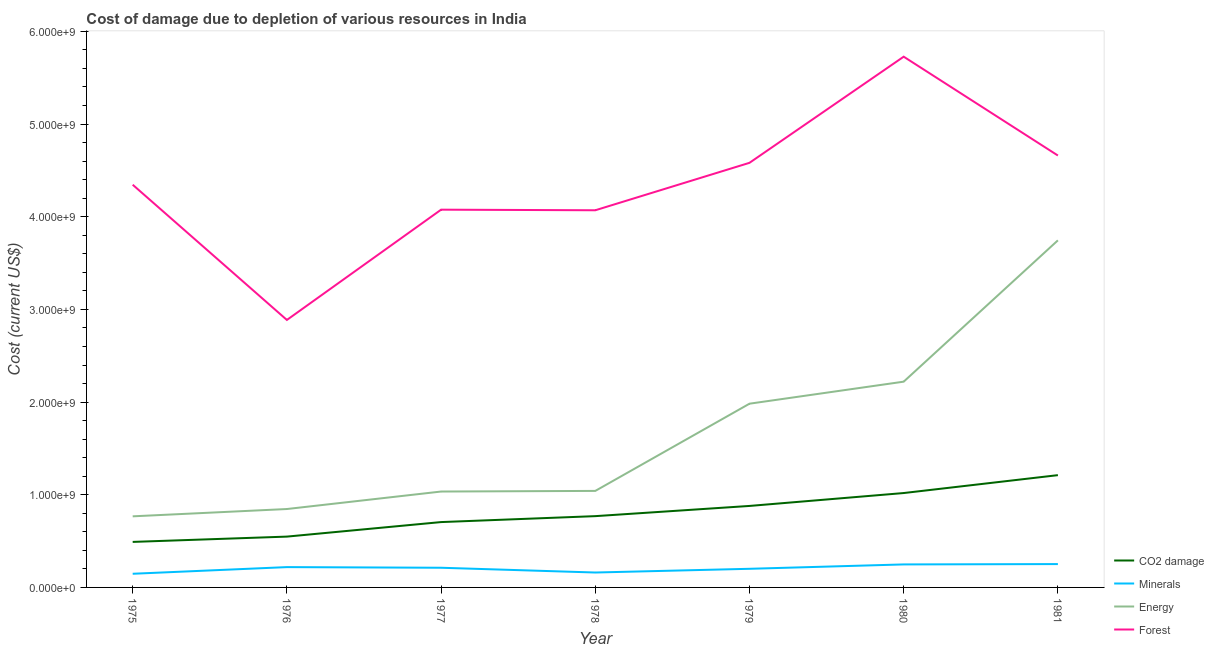What is the cost of damage due to depletion of coal in 1979?
Your response must be concise. 8.79e+08. Across all years, what is the maximum cost of damage due to depletion of minerals?
Give a very brief answer. 2.52e+08. Across all years, what is the minimum cost of damage due to depletion of forests?
Make the answer very short. 2.89e+09. In which year was the cost of damage due to depletion of energy minimum?
Provide a succinct answer. 1975. What is the total cost of damage due to depletion of coal in the graph?
Your response must be concise. 5.62e+09. What is the difference between the cost of damage due to depletion of forests in 1976 and that in 1978?
Keep it short and to the point. -1.18e+09. What is the difference between the cost of damage due to depletion of minerals in 1978 and the cost of damage due to depletion of forests in 1976?
Ensure brevity in your answer.  -2.73e+09. What is the average cost of damage due to depletion of minerals per year?
Keep it short and to the point. 2.06e+08. In the year 1978, what is the difference between the cost of damage due to depletion of energy and cost of damage due to depletion of forests?
Make the answer very short. -3.03e+09. What is the ratio of the cost of damage due to depletion of forests in 1978 to that in 1980?
Make the answer very short. 0.71. Is the cost of damage due to depletion of forests in 1975 less than that in 1976?
Make the answer very short. No. Is the difference between the cost of damage due to depletion of forests in 1976 and 1981 greater than the difference between the cost of damage due to depletion of coal in 1976 and 1981?
Keep it short and to the point. No. What is the difference between the highest and the second highest cost of damage due to depletion of coal?
Your response must be concise. 1.93e+08. What is the difference between the highest and the lowest cost of damage due to depletion of minerals?
Your response must be concise. 1.05e+08. Is it the case that in every year, the sum of the cost of damage due to depletion of coal and cost of damage due to depletion of minerals is greater than the cost of damage due to depletion of energy?
Give a very brief answer. No. Is the cost of damage due to depletion of coal strictly greater than the cost of damage due to depletion of energy over the years?
Your answer should be compact. No. How many lines are there?
Provide a succinct answer. 4. How many years are there in the graph?
Provide a short and direct response. 7. Are the values on the major ticks of Y-axis written in scientific E-notation?
Offer a terse response. Yes. Where does the legend appear in the graph?
Keep it short and to the point. Bottom right. How many legend labels are there?
Make the answer very short. 4. What is the title of the graph?
Keep it short and to the point. Cost of damage due to depletion of various resources in India . Does "Australia" appear as one of the legend labels in the graph?
Offer a terse response. No. What is the label or title of the X-axis?
Offer a terse response. Year. What is the label or title of the Y-axis?
Keep it short and to the point. Cost (current US$). What is the Cost (current US$) in CO2 damage in 1975?
Provide a succinct answer. 4.91e+08. What is the Cost (current US$) of Minerals in 1975?
Your response must be concise. 1.47e+08. What is the Cost (current US$) in Energy in 1975?
Provide a short and direct response. 7.67e+08. What is the Cost (current US$) in Forest in 1975?
Your answer should be compact. 4.35e+09. What is the Cost (current US$) of CO2 damage in 1976?
Offer a very short reply. 5.48e+08. What is the Cost (current US$) in Minerals in 1976?
Give a very brief answer. 2.19e+08. What is the Cost (current US$) in Energy in 1976?
Give a very brief answer. 8.46e+08. What is the Cost (current US$) in Forest in 1976?
Keep it short and to the point. 2.89e+09. What is the Cost (current US$) of CO2 damage in 1977?
Give a very brief answer. 7.05e+08. What is the Cost (current US$) of Minerals in 1977?
Your answer should be very brief. 2.12e+08. What is the Cost (current US$) of Energy in 1977?
Ensure brevity in your answer.  1.03e+09. What is the Cost (current US$) in Forest in 1977?
Offer a very short reply. 4.08e+09. What is the Cost (current US$) in CO2 damage in 1978?
Provide a short and direct response. 7.69e+08. What is the Cost (current US$) in Minerals in 1978?
Your answer should be very brief. 1.61e+08. What is the Cost (current US$) of Energy in 1978?
Provide a succinct answer. 1.04e+09. What is the Cost (current US$) in Forest in 1978?
Your answer should be compact. 4.07e+09. What is the Cost (current US$) in CO2 damage in 1979?
Provide a succinct answer. 8.79e+08. What is the Cost (current US$) of Minerals in 1979?
Ensure brevity in your answer.  2.01e+08. What is the Cost (current US$) in Energy in 1979?
Your response must be concise. 1.98e+09. What is the Cost (current US$) in Forest in 1979?
Your answer should be very brief. 4.58e+09. What is the Cost (current US$) of CO2 damage in 1980?
Your answer should be very brief. 1.02e+09. What is the Cost (current US$) in Minerals in 1980?
Provide a succinct answer. 2.48e+08. What is the Cost (current US$) of Energy in 1980?
Provide a succinct answer. 2.22e+09. What is the Cost (current US$) in Forest in 1980?
Give a very brief answer. 5.73e+09. What is the Cost (current US$) in CO2 damage in 1981?
Offer a very short reply. 1.21e+09. What is the Cost (current US$) in Minerals in 1981?
Keep it short and to the point. 2.52e+08. What is the Cost (current US$) in Energy in 1981?
Give a very brief answer. 3.75e+09. What is the Cost (current US$) in Forest in 1981?
Your answer should be very brief. 4.66e+09. Across all years, what is the maximum Cost (current US$) in CO2 damage?
Offer a terse response. 1.21e+09. Across all years, what is the maximum Cost (current US$) in Minerals?
Your answer should be very brief. 2.52e+08. Across all years, what is the maximum Cost (current US$) in Energy?
Ensure brevity in your answer.  3.75e+09. Across all years, what is the maximum Cost (current US$) of Forest?
Offer a very short reply. 5.73e+09. Across all years, what is the minimum Cost (current US$) of CO2 damage?
Provide a short and direct response. 4.91e+08. Across all years, what is the minimum Cost (current US$) in Minerals?
Your answer should be compact. 1.47e+08. Across all years, what is the minimum Cost (current US$) in Energy?
Make the answer very short. 7.67e+08. Across all years, what is the minimum Cost (current US$) in Forest?
Offer a very short reply. 2.89e+09. What is the total Cost (current US$) in CO2 damage in the graph?
Your response must be concise. 5.62e+09. What is the total Cost (current US$) of Minerals in the graph?
Offer a terse response. 1.44e+09. What is the total Cost (current US$) in Energy in the graph?
Provide a succinct answer. 1.16e+1. What is the total Cost (current US$) of Forest in the graph?
Your answer should be compact. 3.03e+1. What is the difference between the Cost (current US$) of CO2 damage in 1975 and that in 1976?
Your response must be concise. -5.71e+07. What is the difference between the Cost (current US$) of Minerals in 1975 and that in 1976?
Make the answer very short. -7.18e+07. What is the difference between the Cost (current US$) of Energy in 1975 and that in 1976?
Your response must be concise. -7.88e+07. What is the difference between the Cost (current US$) in Forest in 1975 and that in 1976?
Provide a short and direct response. 1.46e+09. What is the difference between the Cost (current US$) in CO2 damage in 1975 and that in 1977?
Give a very brief answer. -2.14e+08. What is the difference between the Cost (current US$) in Minerals in 1975 and that in 1977?
Provide a succinct answer. -6.49e+07. What is the difference between the Cost (current US$) of Energy in 1975 and that in 1977?
Provide a short and direct response. -2.67e+08. What is the difference between the Cost (current US$) in Forest in 1975 and that in 1977?
Provide a short and direct response. 2.69e+08. What is the difference between the Cost (current US$) in CO2 damage in 1975 and that in 1978?
Provide a short and direct response. -2.78e+08. What is the difference between the Cost (current US$) in Minerals in 1975 and that in 1978?
Give a very brief answer. -1.35e+07. What is the difference between the Cost (current US$) of Energy in 1975 and that in 1978?
Keep it short and to the point. -2.74e+08. What is the difference between the Cost (current US$) in Forest in 1975 and that in 1978?
Your answer should be very brief. 2.76e+08. What is the difference between the Cost (current US$) of CO2 damage in 1975 and that in 1979?
Your answer should be compact. -3.88e+08. What is the difference between the Cost (current US$) in Minerals in 1975 and that in 1979?
Give a very brief answer. -5.36e+07. What is the difference between the Cost (current US$) in Energy in 1975 and that in 1979?
Keep it short and to the point. -1.22e+09. What is the difference between the Cost (current US$) in Forest in 1975 and that in 1979?
Provide a short and direct response. -2.36e+08. What is the difference between the Cost (current US$) of CO2 damage in 1975 and that in 1980?
Make the answer very short. -5.27e+08. What is the difference between the Cost (current US$) in Minerals in 1975 and that in 1980?
Your answer should be very brief. -1.01e+08. What is the difference between the Cost (current US$) of Energy in 1975 and that in 1980?
Your answer should be very brief. -1.45e+09. What is the difference between the Cost (current US$) in Forest in 1975 and that in 1980?
Offer a very short reply. -1.38e+09. What is the difference between the Cost (current US$) of CO2 damage in 1975 and that in 1981?
Your response must be concise. -7.20e+08. What is the difference between the Cost (current US$) in Minerals in 1975 and that in 1981?
Provide a succinct answer. -1.05e+08. What is the difference between the Cost (current US$) of Energy in 1975 and that in 1981?
Offer a terse response. -2.98e+09. What is the difference between the Cost (current US$) in Forest in 1975 and that in 1981?
Your answer should be compact. -3.15e+08. What is the difference between the Cost (current US$) of CO2 damage in 1976 and that in 1977?
Your answer should be compact. -1.57e+08. What is the difference between the Cost (current US$) in Minerals in 1976 and that in 1977?
Offer a very short reply. 6.86e+06. What is the difference between the Cost (current US$) in Energy in 1976 and that in 1977?
Keep it short and to the point. -1.89e+08. What is the difference between the Cost (current US$) in Forest in 1976 and that in 1977?
Give a very brief answer. -1.19e+09. What is the difference between the Cost (current US$) of CO2 damage in 1976 and that in 1978?
Your answer should be very brief. -2.21e+08. What is the difference between the Cost (current US$) in Minerals in 1976 and that in 1978?
Offer a terse response. 5.84e+07. What is the difference between the Cost (current US$) in Energy in 1976 and that in 1978?
Your answer should be compact. -1.95e+08. What is the difference between the Cost (current US$) of Forest in 1976 and that in 1978?
Give a very brief answer. -1.18e+09. What is the difference between the Cost (current US$) in CO2 damage in 1976 and that in 1979?
Your answer should be compact. -3.31e+08. What is the difference between the Cost (current US$) of Minerals in 1976 and that in 1979?
Make the answer very short. 1.82e+07. What is the difference between the Cost (current US$) in Energy in 1976 and that in 1979?
Offer a very short reply. -1.14e+09. What is the difference between the Cost (current US$) of Forest in 1976 and that in 1979?
Keep it short and to the point. -1.70e+09. What is the difference between the Cost (current US$) of CO2 damage in 1976 and that in 1980?
Your answer should be very brief. -4.70e+08. What is the difference between the Cost (current US$) in Minerals in 1976 and that in 1980?
Your response must be concise. -2.91e+07. What is the difference between the Cost (current US$) in Energy in 1976 and that in 1980?
Offer a terse response. -1.37e+09. What is the difference between the Cost (current US$) in Forest in 1976 and that in 1980?
Provide a short and direct response. -2.84e+09. What is the difference between the Cost (current US$) in CO2 damage in 1976 and that in 1981?
Make the answer very short. -6.63e+08. What is the difference between the Cost (current US$) in Minerals in 1976 and that in 1981?
Offer a very short reply. -3.27e+07. What is the difference between the Cost (current US$) in Energy in 1976 and that in 1981?
Your answer should be very brief. -2.90e+09. What is the difference between the Cost (current US$) in Forest in 1976 and that in 1981?
Offer a terse response. -1.77e+09. What is the difference between the Cost (current US$) of CO2 damage in 1977 and that in 1978?
Offer a very short reply. -6.41e+07. What is the difference between the Cost (current US$) of Minerals in 1977 and that in 1978?
Keep it short and to the point. 5.15e+07. What is the difference between the Cost (current US$) in Energy in 1977 and that in 1978?
Provide a succinct answer. -6.77e+06. What is the difference between the Cost (current US$) in Forest in 1977 and that in 1978?
Your answer should be compact. 6.45e+06. What is the difference between the Cost (current US$) of CO2 damage in 1977 and that in 1979?
Give a very brief answer. -1.74e+08. What is the difference between the Cost (current US$) of Minerals in 1977 and that in 1979?
Make the answer very short. 1.14e+07. What is the difference between the Cost (current US$) of Energy in 1977 and that in 1979?
Ensure brevity in your answer.  -9.48e+08. What is the difference between the Cost (current US$) in Forest in 1977 and that in 1979?
Give a very brief answer. -5.06e+08. What is the difference between the Cost (current US$) of CO2 damage in 1977 and that in 1980?
Offer a terse response. -3.13e+08. What is the difference between the Cost (current US$) in Minerals in 1977 and that in 1980?
Your response must be concise. -3.60e+07. What is the difference between the Cost (current US$) of Energy in 1977 and that in 1980?
Offer a very short reply. -1.19e+09. What is the difference between the Cost (current US$) of Forest in 1977 and that in 1980?
Provide a short and direct response. -1.65e+09. What is the difference between the Cost (current US$) in CO2 damage in 1977 and that in 1981?
Offer a very short reply. -5.06e+08. What is the difference between the Cost (current US$) of Minerals in 1977 and that in 1981?
Your answer should be compact. -3.96e+07. What is the difference between the Cost (current US$) of Energy in 1977 and that in 1981?
Your response must be concise. -2.71e+09. What is the difference between the Cost (current US$) of Forest in 1977 and that in 1981?
Ensure brevity in your answer.  -5.84e+08. What is the difference between the Cost (current US$) of CO2 damage in 1978 and that in 1979?
Keep it short and to the point. -1.10e+08. What is the difference between the Cost (current US$) in Minerals in 1978 and that in 1979?
Give a very brief answer. -4.01e+07. What is the difference between the Cost (current US$) in Energy in 1978 and that in 1979?
Your answer should be compact. -9.41e+08. What is the difference between the Cost (current US$) in Forest in 1978 and that in 1979?
Give a very brief answer. -5.12e+08. What is the difference between the Cost (current US$) in CO2 damage in 1978 and that in 1980?
Provide a succinct answer. -2.49e+08. What is the difference between the Cost (current US$) in Minerals in 1978 and that in 1980?
Your response must be concise. -8.75e+07. What is the difference between the Cost (current US$) in Energy in 1978 and that in 1980?
Provide a short and direct response. -1.18e+09. What is the difference between the Cost (current US$) of Forest in 1978 and that in 1980?
Your answer should be very brief. -1.66e+09. What is the difference between the Cost (current US$) in CO2 damage in 1978 and that in 1981?
Provide a short and direct response. -4.42e+08. What is the difference between the Cost (current US$) of Minerals in 1978 and that in 1981?
Your response must be concise. -9.11e+07. What is the difference between the Cost (current US$) of Energy in 1978 and that in 1981?
Make the answer very short. -2.70e+09. What is the difference between the Cost (current US$) of Forest in 1978 and that in 1981?
Ensure brevity in your answer.  -5.91e+08. What is the difference between the Cost (current US$) of CO2 damage in 1979 and that in 1980?
Provide a succinct answer. -1.39e+08. What is the difference between the Cost (current US$) in Minerals in 1979 and that in 1980?
Keep it short and to the point. -4.73e+07. What is the difference between the Cost (current US$) in Energy in 1979 and that in 1980?
Offer a terse response. -2.38e+08. What is the difference between the Cost (current US$) of Forest in 1979 and that in 1980?
Offer a very short reply. -1.15e+09. What is the difference between the Cost (current US$) in CO2 damage in 1979 and that in 1981?
Keep it short and to the point. -3.32e+08. What is the difference between the Cost (current US$) of Minerals in 1979 and that in 1981?
Offer a terse response. -5.10e+07. What is the difference between the Cost (current US$) in Energy in 1979 and that in 1981?
Keep it short and to the point. -1.76e+09. What is the difference between the Cost (current US$) of Forest in 1979 and that in 1981?
Your answer should be compact. -7.88e+07. What is the difference between the Cost (current US$) of CO2 damage in 1980 and that in 1981?
Give a very brief answer. -1.93e+08. What is the difference between the Cost (current US$) in Minerals in 1980 and that in 1981?
Offer a terse response. -3.63e+06. What is the difference between the Cost (current US$) in Energy in 1980 and that in 1981?
Give a very brief answer. -1.52e+09. What is the difference between the Cost (current US$) in Forest in 1980 and that in 1981?
Offer a very short reply. 1.07e+09. What is the difference between the Cost (current US$) in CO2 damage in 1975 and the Cost (current US$) in Minerals in 1976?
Keep it short and to the point. 2.72e+08. What is the difference between the Cost (current US$) of CO2 damage in 1975 and the Cost (current US$) of Energy in 1976?
Ensure brevity in your answer.  -3.55e+08. What is the difference between the Cost (current US$) in CO2 damage in 1975 and the Cost (current US$) in Forest in 1976?
Give a very brief answer. -2.40e+09. What is the difference between the Cost (current US$) in Minerals in 1975 and the Cost (current US$) in Energy in 1976?
Your answer should be compact. -6.99e+08. What is the difference between the Cost (current US$) of Minerals in 1975 and the Cost (current US$) of Forest in 1976?
Provide a succinct answer. -2.74e+09. What is the difference between the Cost (current US$) of Energy in 1975 and the Cost (current US$) of Forest in 1976?
Provide a short and direct response. -2.12e+09. What is the difference between the Cost (current US$) of CO2 damage in 1975 and the Cost (current US$) of Minerals in 1977?
Ensure brevity in your answer.  2.79e+08. What is the difference between the Cost (current US$) in CO2 damage in 1975 and the Cost (current US$) in Energy in 1977?
Provide a succinct answer. -5.43e+08. What is the difference between the Cost (current US$) in CO2 damage in 1975 and the Cost (current US$) in Forest in 1977?
Give a very brief answer. -3.59e+09. What is the difference between the Cost (current US$) of Minerals in 1975 and the Cost (current US$) of Energy in 1977?
Make the answer very short. -8.87e+08. What is the difference between the Cost (current US$) in Minerals in 1975 and the Cost (current US$) in Forest in 1977?
Your answer should be very brief. -3.93e+09. What is the difference between the Cost (current US$) in Energy in 1975 and the Cost (current US$) in Forest in 1977?
Make the answer very short. -3.31e+09. What is the difference between the Cost (current US$) in CO2 damage in 1975 and the Cost (current US$) in Minerals in 1978?
Your answer should be very brief. 3.30e+08. What is the difference between the Cost (current US$) of CO2 damage in 1975 and the Cost (current US$) of Energy in 1978?
Ensure brevity in your answer.  -5.50e+08. What is the difference between the Cost (current US$) of CO2 damage in 1975 and the Cost (current US$) of Forest in 1978?
Keep it short and to the point. -3.58e+09. What is the difference between the Cost (current US$) in Minerals in 1975 and the Cost (current US$) in Energy in 1978?
Your answer should be very brief. -8.94e+08. What is the difference between the Cost (current US$) in Minerals in 1975 and the Cost (current US$) in Forest in 1978?
Offer a terse response. -3.92e+09. What is the difference between the Cost (current US$) of Energy in 1975 and the Cost (current US$) of Forest in 1978?
Your answer should be compact. -3.30e+09. What is the difference between the Cost (current US$) in CO2 damage in 1975 and the Cost (current US$) in Minerals in 1979?
Give a very brief answer. 2.90e+08. What is the difference between the Cost (current US$) in CO2 damage in 1975 and the Cost (current US$) in Energy in 1979?
Keep it short and to the point. -1.49e+09. What is the difference between the Cost (current US$) in CO2 damage in 1975 and the Cost (current US$) in Forest in 1979?
Your answer should be very brief. -4.09e+09. What is the difference between the Cost (current US$) of Minerals in 1975 and the Cost (current US$) of Energy in 1979?
Provide a succinct answer. -1.84e+09. What is the difference between the Cost (current US$) in Minerals in 1975 and the Cost (current US$) in Forest in 1979?
Provide a short and direct response. -4.43e+09. What is the difference between the Cost (current US$) of Energy in 1975 and the Cost (current US$) of Forest in 1979?
Give a very brief answer. -3.81e+09. What is the difference between the Cost (current US$) of CO2 damage in 1975 and the Cost (current US$) of Minerals in 1980?
Provide a short and direct response. 2.43e+08. What is the difference between the Cost (current US$) in CO2 damage in 1975 and the Cost (current US$) in Energy in 1980?
Give a very brief answer. -1.73e+09. What is the difference between the Cost (current US$) in CO2 damage in 1975 and the Cost (current US$) in Forest in 1980?
Offer a very short reply. -5.24e+09. What is the difference between the Cost (current US$) in Minerals in 1975 and the Cost (current US$) in Energy in 1980?
Provide a short and direct response. -2.07e+09. What is the difference between the Cost (current US$) in Minerals in 1975 and the Cost (current US$) in Forest in 1980?
Your answer should be very brief. -5.58e+09. What is the difference between the Cost (current US$) of Energy in 1975 and the Cost (current US$) of Forest in 1980?
Offer a terse response. -4.96e+09. What is the difference between the Cost (current US$) of CO2 damage in 1975 and the Cost (current US$) of Minerals in 1981?
Make the answer very short. 2.39e+08. What is the difference between the Cost (current US$) of CO2 damage in 1975 and the Cost (current US$) of Energy in 1981?
Offer a very short reply. -3.25e+09. What is the difference between the Cost (current US$) of CO2 damage in 1975 and the Cost (current US$) of Forest in 1981?
Your answer should be very brief. -4.17e+09. What is the difference between the Cost (current US$) in Minerals in 1975 and the Cost (current US$) in Energy in 1981?
Provide a succinct answer. -3.60e+09. What is the difference between the Cost (current US$) of Minerals in 1975 and the Cost (current US$) of Forest in 1981?
Ensure brevity in your answer.  -4.51e+09. What is the difference between the Cost (current US$) of Energy in 1975 and the Cost (current US$) of Forest in 1981?
Your answer should be compact. -3.89e+09. What is the difference between the Cost (current US$) in CO2 damage in 1976 and the Cost (current US$) in Minerals in 1977?
Ensure brevity in your answer.  3.36e+08. What is the difference between the Cost (current US$) in CO2 damage in 1976 and the Cost (current US$) in Energy in 1977?
Offer a very short reply. -4.86e+08. What is the difference between the Cost (current US$) in CO2 damage in 1976 and the Cost (current US$) in Forest in 1977?
Offer a terse response. -3.53e+09. What is the difference between the Cost (current US$) in Minerals in 1976 and the Cost (current US$) in Energy in 1977?
Keep it short and to the point. -8.16e+08. What is the difference between the Cost (current US$) of Minerals in 1976 and the Cost (current US$) of Forest in 1977?
Provide a short and direct response. -3.86e+09. What is the difference between the Cost (current US$) in Energy in 1976 and the Cost (current US$) in Forest in 1977?
Provide a succinct answer. -3.23e+09. What is the difference between the Cost (current US$) in CO2 damage in 1976 and the Cost (current US$) in Minerals in 1978?
Offer a terse response. 3.88e+08. What is the difference between the Cost (current US$) of CO2 damage in 1976 and the Cost (current US$) of Energy in 1978?
Make the answer very short. -4.93e+08. What is the difference between the Cost (current US$) in CO2 damage in 1976 and the Cost (current US$) in Forest in 1978?
Ensure brevity in your answer.  -3.52e+09. What is the difference between the Cost (current US$) in Minerals in 1976 and the Cost (current US$) in Energy in 1978?
Give a very brief answer. -8.22e+08. What is the difference between the Cost (current US$) of Minerals in 1976 and the Cost (current US$) of Forest in 1978?
Keep it short and to the point. -3.85e+09. What is the difference between the Cost (current US$) in Energy in 1976 and the Cost (current US$) in Forest in 1978?
Offer a terse response. -3.22e+09. What is the difference between the Cost (current US$) of CO2 damage in 1976 and the Cost (current US$) of Minerals in 1979?
Give a very brief answer. 3.47e+08. What is the difference between the Cost (current US$) of CO2 damage in 1976 and the Cost (current US$) of Energy in 1979?
Your response must be concise. -1.43e+09. What is the difference between the Cost (current US$) in CO2 damage in 1976 and the Cost (current US$) in Forest in 1979?
Keep it short and to the point. -4.03e+09. What is the difference between the Cost (current US$) in Minerals in 1976 and the Cost (current US$) in Energy in 1979?
Give a very brief answer. -1.76e+09. What is the difference between the Cost (current US$) in Minerals in 1976 and the Cost (current US$) in Forest in 1979?
Give a very brief answer. -4.36e+09. What is the difference between the Cost (current US$) in Energy in 1976 and the Cost (current US$) in Forest in 1979?
Offer a terse response. -3.74e+09. What is the difference between the Cost (current US$) in CO2 damage in 1976 and the Cost (current US$) in Minerals in 1980?
Your answer should be very brief. 3.00e+08. What is the difference between the Cost (current US$) in CO2 damage in 1976 and the Cost (current US$) in Energy in 1980?
Make the answer very short. -1.67e+09. What is the difference between the Cost (current US$) in CO2 damage in 1976 and the Cost (current US$) in Forest in 1980?
Provide a succinct answer. -5.18e+09. What is the difference between the Cost (current US$) of Minerals in 1976 and the Cost (current US$) of Energy in 1980?
Provide a succinct answer. -2.00e+09. What is the difference between the Cost (current US$) in Minerals in 1976 and the Cost (current US$) in Forest in 1980?
Your answer should be very brief. -5.51e+09. What is the difference between the Cost (current US$) of Energy in 1976 and the Cost (current US$) of Forest in 1980?
Provide a succinct answer. -4.88e+09. What is the difference between the Cost (current US$) of CO2 damage in 1976 and the Cost (current US$) of Minerals in 1981?
Your response must be concise. 2.96e+08. What is the difference between the Cost (current US$) of CO2 damage in 1976 and the Cost (current US$) of Energy in 1981?
Your answer should be very brief. -3.20e+09. What is the difference between the Cost (current US$) in CO2 damage in 1976 and the Cost (current US$) in Forest in 1981?
Ensure brevity in your answer.  -4.11e+09. What is the difference between the Cost (current US$) in Minerals in 1976 and the Cost (current US$) in Energy in 1981?
Keep it short and to the point. -3.53e+09. What is the difference between the Cost (current US$) in Minerals in 1976 and the Cost (current US$) in Forest in 1981?
Provide a short and direct response. -4.44e+09. What is the difference between the Cost (current US$) in Energy in 1976 and the Cost (current US$) in Forest in 1981?
Your answer should be compact. -3.81e+09. What is the difference between the Cost (current US$) of CO2 damage in 1977 and the Cost (current US$) of Minerals in 1978?
Keep it short and to the point. 5.44e+08. What is the difference between the Cost (current US$) in CO2 damage in 1977 and the Cost (current US$) in Energy in 1978?
Offer a terse response. -3.36e+08. What is the difference between the Cost (current US$) in CO2 damage in 1977 and the Cost (current US$) in Forest in 1978?
Make the answer very short. -3.36e+09. What is the difference between the Cost (current US$) of Minerals in 1977 and the Cost (current US$) of Energy in 1978?
Ensure brevity in your answer.  -8.29e+08. What is the difference between the Cost (current US$) of Minerals in 1977 and the Cost (current US$) of Forest in 1978?
Your answer should be very brief. -3.86e+09. What is the difference between the Cost (current US$) of Energy in 1977 and the Cost (current US$) of Forest in 1978?
Provide a short and direct response. -3.04e+09. What is the difference between the Cost (current US$) of CO2 damage in 1977 and the Cost (current US$) of Minerals in 1979?
Provide a succinct answer. 5.04e+08. What is the difference between the Cost (current US$) in CO2 damage in 1977 and the Cost (current US$) in Energy in 1979?
Make the answer very short. -1.28e+09. What is the difference between the Cost (current US$) of CO2 damage in 1977 and the Cost (current US$) of Forest in 1979?
Your answer should be compact. -3.88e+09. What is the difference between the Cost (current US$) of Minerals in 1977 and the Cost (current US$) of Energy in 1979?
Provide a succinct answer. -1.77e+09. What is the difference between the Cost (current US$) in Minerals in 1977 and the Cost (current US$) in Forest in 1979?
Offer a terse response. -4.37e+09. What is the difference between the Cost (current US$) in Energy in 1977 and the Cost (current US$) in Forest in 1979?
Provide a succinct answer. -3.55e+09. What is the difference between the Cost (current US$) of CO2 damage in 1977 and the Cost (current US$) of Minerals in 1980?
Make the answer very short. 4.57e+08. What is the difference between the Cost (current US$) in CO2 damage in 1977 and the Cost (current US$) in Energy in 1980?
Make the answer very short. -1.52e+09. What is the difference between the Cost (current US$) in CO2 damage in 1977 and the Cost (current US$) in Forest in 1980?
Make the answer very short. -5.02e+09. What is the difference between the Cost (current US$) in Minerals in 1977 and the Cost (current US$) in Energy in 1980?
Offer a very short reply. -2.01e+09. What is the difference between the Cost (current US$) of Minerals in 1977 and the Cost (current US$) of Forest in 1980?
Give a very brief answer. -5.51e+09. What is the difference between the Cost (current US$) in Energy in 1977 and the Cost (current US$) in Forest in 1980?
Your answer should be compact. -4.69e+09. What is the difference between the Cost (current US$) of CO2 damage in 1977 and the Cost (current US$) of Minerals in 1981?
Ensure brevity in your answer.  4.53e+08. What is the difference between the Cost (current US$) in CO2 damage in 1977 and the Cost (current US$) in Energy in 1981?
Your response must be concise. -3.04e+09. What is the difference between the Cost (current US$) in CO2 damage in 1977 and the Cost (current US$) in Forest in 1981?
Your answer should be compact. -3.96e+09. What is the difference between the Cost (current US$) in Minerals in 1977 and the Cost (current US$) in Energy in 1981?
Ensure brevity in your answer.  -3.53e+09. What is the difference between the Cost (current US$) of Minerals in 1977 and the Cost (current US$) of Forest in 1981?
Give a very brief answer. -4.45e+09. What is the difference between the Cost (current US$) of Energy in 1977 and the Cost (current US$) of Forest in 1981?
Your answer should be very brief. -3.63e+09. What is the difference between the Cost (current US$) of CO2 damage in 1978 and the Cost (current US$) of Minerals in 1979?
Provide a short and direct response. 5.68e+08. What is the difference between the Cost (current US$) of CO2 damage in 1978 and the Cost (current US$) of Energy in 1979?
Make the answer very short. -1.21e+09. What is the difference between the Cost (current US$) of CO2 damage in 1978 and the Cost (current US$) of Forest in 1979?
Offer a very short reply. -3.81e+09. What is the difference between the Cost (current US$) in Minerals in 1978 and the Cost (current US$) in Energy in 1979?
Make the answer very short. -1.82e+09. What is the difference between the Cost (current US$) in Minerals in 1978 and the Cost (current US$) in Forest in 1979?
Keep it short and to the point. -4.42e+09. What is the difference between the Cost (current US$) in Energy in 1978 and the Cost (current US$) in Forest in 1979?
Keep it short and to the point. -3.54e+09. What is the difference between the Cost (current US$) in CO2 damage in 1978 and the Cost (current US$) in Minerals in 1980?
Your answer should be very brief. 5.21e+08. What is the difference between the Cost (current US$) of CO2 damage in 1978 and the Cost (current US$) of Energy in 1980?
Your answer should be compact. -1.45e+09. What is the difference between the Cost (current US$) in CO2 damage in 1978 and the Cost (current US$) in Forest in 1980?
Make the answer very short. -4.96e+09. What is the difference between the Cost (current US$) in Minerals in 1978 and the Cost (current US$) in Energy in 1980?
Your answer should be very brief. -2.06e+09. What is the difference between the Cost (current US$) in Minerals in 1978 and the Cost (current US$) in Forest in 1980?
Your response must be concise. -5.57e+09. What is the difference between the Cost (current US$) of Energy in 1978 and the Cost (current US$) of Forest in 1980?
Your answer should be compact. -4.69e+09. What is the difference between the Cost (current US$) in CO2 damage in 1978 and the Cost (current US$) in Minerals in 1981?
Your answer should be compact. 5.17e+08. What is the difference between the Cost (current US$) of CO2 damage in 1978 and the Cost (current US$) of Energy in 1981?
Give a very brief answer. -2.98e+09. What is the difference between the Cost (current US$) in CO2 damage in 1978 and the Cost (current US$) in Forest in 1981?
Provide a succinct answer. -3.89e+09. What is the difference between the Cost (current US$) in Minerals in 1978 and the Cost (current US$) in Energy in 1981?
Provide a short and direct response. -3.58e+09. What is the difference between the Cost (current US$) of Minerals in 1978 and the Cost (current US$) of Forest in 1981?
Make the answer very short. -4.50e+09. What is the difference between the Cost (current US$) of Energy in 1978 and the Cost (current US$) of Forest in 1981?
Offer a terse response. -3.62e+09. What is the difference between the Cost (current US$) in CO2 damage in 1979 and the Cost (current US$) in Minerals in 1980?
Provide a short and direct response. 6.31e+08. What is the difference between the Cost (current US$) in CO2 damage in 1979 and the Cost (current US$) in Energy in 1980?
Your response must be concise. -1.34e+09. What is the difference between the Cost (current US$) of CO2 damage in 1979 and the Cost (current US$) of Forest in 1980?
Your response must be concise. -4.85e+09. What is the difference between the Cost (current US$) of Minerals in 1979 and the Cost (current US$) of Energy in 1980?
Offer a terse response. -2.02e+09. What is the difference between the Cost (current US$) of Minerals in 1979 and the Cost (current US$) of Forest in 1980?
Provide a short and direct response. -5.53e+09. What is the difference between the Cost (current US$) in Energy in 1979 and the Cost (current US$) in Forest in 1980?
Offer a very short reply. -3.74e+09. What is the difference between the Cost (current US$) in CO2 damage in 1979 and the Cost (current US$) in Minerals in 1981?
Ensure brevity in your answer.  6.27e+08. What is the difference between the Cost (current US$) of CO2 damage in 1979 and the Cost (current US$) of Energy in 1981?
Your answer should be very brief. -2.87e+09. What is the difference between the Cost (current US$) of CO2 damage in 1979 and the Cost (current US$) of Forest in 1981?
Your answer should be very brief. -3.78e+09. What is the difference between the Cost (current US$) of Minerals in 1979 and the Cost (current US$) of Energy in 1981?
Give a very brief answer. -3.54e+09. What is the difference between the Cost (current US$) in Minerals in 1979 and the Cost (current US$) in Forest in 1981?
Offer a terse response. -4.46e+09. What is the difference between the Cost (current US$) of Energy in 1979 and the Cost (current US$) of Forest in 1981?
Provide a short and direct response. -2.68e+09. What is the difference between the Cost (current US$) of CO2 damage in 1980 and the Cost (current US$) of Minerals in 1981?
Offer a terse response. 7.67e+08. What is the difference between the Cost (current US$) in CO2 damage in 1980 and the Cost (current US$) in Energy in 1981?
Your response must be concise. -2.73e+09. What is the difference between the Cost (current US$) in CO2 damage in 1980 and the Cost (current US$) in Forest in 1981?
Provide a short and direct response. -3.64e+09. What is the difference between the Cost (current US$) in Minerals in 1980 and the Cost (current US$) in Energy in 1981?
Offer a very short reply. -3.50e+09. What is the difference between the Cost (current US$) of Minerals in 1980 and the Cost (current US$) of Forest in 1981?
Keep it short and to the point. -4.41e+09. What is the difference between the Cost (current US$) in Energy in 1980 and the Cost (current US$) in Forest in 1981?
Your response must be concise. -2.44e+09. What is the average Cost (current US$) in CO2 damage per year?
Make the answer very short. 8.03e+08. What is the average Cost (current US$) in Minerals per year?
Provide a succinct answer. 2.06e+08. What is the average Cost (current US$) in Energy per year?
Your response must be concise. 1.66e+09. What is the average Cost (current US$) of Forest per year?
Your response must be concise. 4.34e+09. In the year 1975, what is the difference between the Cost (current US$) of CO2 damage and Cost (current US$) of Minerals?
Ensure brevity in your answer.  3.44e+08. In the year 1975, what is the difference between the Cost (current US$) in CO2 damage and Cost (current US$) in Energy?
Your response must be concise. -2.76e+08. In the year 1975, what is the difference between the Cost (current US$) of CO2 damage and Cost (current US$) of Forest?
Offer a terse response. -3.85e+09. In the year 1975, what is the difference between the Cost (current US$) in Minerals and Cost (current US$) in Energy?
Your response must be concise. -6.20e+08. In the year 1975, what is the difference between the Cost (current US$) in Minerals and Cost (current US$) in Forest?
Give a very brief answer. -4.20e+09. In the year 1975, what is the difference between the Cost (current US$) in Energy and Cost (current US$) in Forest?
Ensure brevity in your answer.  -3.58e+09. In the year 1976, what is the difference between the Cost (current US$) in CO2 damage and Cost (current US$) in Minerals?
Provide a short and direct response. 3.29e+08. In the year 1976, what is the difference between the Cost (current US$) in CO2 damage and Cost (current US$) in Energy?
Your response must be concise. -2.98e+08. In the year 1976, what is the difference between the Cost (current US$) of CO2 damage and Cost (current US$) of Forest?
Offer a terse response. -2.34e+09. In the year 1976, what is the difference between the Cost (current US$) of Minerals and Cost (current US$) of Energy?
Offer a terse response. -6.27e+08. In the year 1976, what is the difference between the Cost (current US$) of Minerals and Cost (current US$) of Forest?
Your answer should be very brief. -2.67e+09. In the year 1976, what is the difference between the Cost (current US$) in Energy and Cost (current US$) in Forest?
Your answer should be very brief. -2.04e+09. In the year 1977, what is the difference between the Cost (current US$) in CO2 damage and Cost (current US$) in Minerals?
Your response must be concise. 4.93e+08. In the year 1977, what is the difference between the Cost (current US$) in CO2 damage and Cost (current US$) in Energy?
Make the answer very short. -3.30e+08. In the year 1977, what is the difference between the Cost (current US$) of CO2 damage and Cost (current US$) of Forest?
Offer a very short reply. -3.37e+09. In the year 1977, what is the difference between the Cost (current US$) in Minerals and Cost (current US$) in Energy?
Keep it short and to the point. -8.22e+08. In the year 1977, what is the difference between the Cost (current US$) of Minerals and Cost (current US$) of Forest?
Make the answer very short. -3.86e+09. In the year 1977, what is the difference between the Cost (current US$) of Energy and Cost (current US$) of Forest?
Give a very brief answer. -3.04e+09. In the year 1978, what is the difference between the Cost (current US$) in CO2 damage and Cost (current US$) in Minerals?
Your answer should be compact. 6.08e+08. In the year 1978, what is the difference between the Cost (current US$) of CO2 damage and Cost (current US$) of Energy?
Provide a short and direct response. -2.72e+08. In the year 1978, what is the difference between the Cost (current US$) in CO2 damage and Cost (current US$) in Forest?
Keep it short and to the point. -3.30e+09. In the year 1978, what is the difference between the Cost (current US$) of Minerals and Cost (current US$) of Energy?
Keep it short and to the point. -8.81e+08. In the year 1978, what is the difference between the Cost (current US$) of Minerals and Cost (current US$) of Forest?
Your answer should be very brief. -3.91e+09. In the year 1978, what is the difference between the Cost (current US$) in Energy and Cost (current US$) in Forest?
Your answer should be compact. -3.03e+09. In the year 1979, what is the difference between the Cost (current US$) in CO2 damage and Cost (current US$) in Minerals?
Your response must be concise. 6.78e+08. In the year 1979, what is the difference between the Cost (current US$) in CO2 damage and Cost (current US$) in Energy?
Offer a very short reply. -1.10e+09. In the year 1979, what is the difference between the Cost (current US$) in CO2 damage and Cost (current US$) in Forest?
Keep it short and to the point. -3.70e+09. In the year 1979, what is the difference between the Cost (current US$) of Minerals and Cost (current US$) of Energy?
Your answer should be compact. -1.78e+09. In the year 1979, what is the difference between the Cost (current US$) in Minerals and Cost (current US$) in Forest?
Your answer should be compact. -4.38e+09. In the year 1979, what is the difference between the Cost (current US$) in Energy and Cost (current US$) in Forest?
Keep it short and to the point. -2.60e+09. In the year 1980, what is the difference between the Cost (current US$) in CO2 damage and Cost (current US$) in Minerals?
Offer a very short reply. 7.70e+08. In the year 1980, what is the difference between the Cost (current US$) of CO2 damage and Cost (current US$) of Energy?
Provide a succinct answer. -1.20e+09. In the year 1980, what is the difference between the Cost (current US$) in CO2 damage and Cost (current US$) in Forest?
Ensure brevity in your answer.  -4.71e+09. In the year 1980, what is the difference between the Cost (current US$) in Minerals and Cost (current US$) in Energy?
Your answer should be compact. -1.97e+09. In the year 1980, what is the difference between the Cost (current US$) of Minerals and Cost (current US$) of Forest?
Your answer should be compact. -5.48e+09. In the year 1980, what is the difference between the Cost (current US$) in Energy and Cost (current US$) in Forest?
Ensure brevity in your answer.  -3.51e+09. In the year 1981, what is the difference between the Cost (current US$) of CO2 damage and Cost (current US$) of Minerals?
Offer a terse response. 9.60e+08. In the year 1981, what is the difference between the Cost (current US$) of CO2 damage and Cost (current US$) of Energy?
Give a very brief answer. -2.53e+09. In the year 1981, what is the difference between the Cost (current US$) of CO2 damage and Cost (current US$) of Forest?
Your answer should be compact. -3.45e+09. In the year 1981, what is the difference between the Cost (current US$) in Minerals and Cost (current US$) in Energy?
Provide a short and direct response. -3.49e+09. In the year 1981, what is the difference between the Cost (current US$) of Minerals and Cost (current US$) of Forest?
Keep it short and to the point. -4.41e+09. In the year 1981, what is the difference between the Cost (current US$) of Energy and Cost (current US$) of Forest?
Your response must be concise. -9.15e+08. What is the ratio of the Cost (current US$) of CO2 damage in 1975 to that in 1976?
Offer a very short reply. 0.9. What is the ratio of the Cost (current US$) of Minerals in 1975 to that in 1976?
Ensure brevity in your answer.  0.67. What is the ratio of the Cost (current US$) in Energy in 1975 to that in 1976?
Offer a terse response. 0.91. What is the ratio of the Cost (current US$) of Forest in 1975 to that in 1976?
Provide a short and direct response. 1.51. What is the ratio of the Cost (current US$) in CO2 damage in 1975 to that in 1977?
Provide a short and direct response. 0.7. What is the ratio of the Cost (current US$) in Minerals in 1975 to that in 1977?
Offer a very short reply. 0.69. What is the ratio of the Cost (current US$) of Energy in 1975 to that in 1977?
Make the answer very short. 0.74. What is the ratio of the Cost (current US$) in Forest in 1975 to that in 1977?
Offer a terse response. 1.07. What is the ratio of the Cost (current US$) in CO2 damage in 1975 to that in 1978?
Keep it short and to the point. 0.64. What is the ratio of the Cost (current US$) of Minerals in 1975 to that in 1978?
Your response must be concise. 0.92. What is the ratio of the Cost (current US$) in Energy in 1975 to that in 1978?
Your response must be concise. 0.74. What is the ratio of the Cost (current US$) in Forest in 1975 to that in 1978?
Make the answer very short. 1.07. What is the ratio of the Cost (current US$) in CO2 damage in 1975 to that in 1979?
Keep it short and to the point. 0.56. What is the ratio of the Cost (current US$) in Minerals in 1975 to that in 1979?
Give a very brief answer. 0.73. What is the ratio of the Cost (current US$) in Energy in 1975 to that in 1979?
Make the answer very short. 0.39. What is the ratio of the Cost (current US$) of Forest in 1975 to that in 1979?
Offer a terse response. 0.95. What is the ratio of the Cost (current US$) of CO2 damage in 1975 to that in 1980?
Your answer should be very brief. 0.48. What is the ratio of the Cost (current US$) in Minerals in 1975 to that in 1980?
Ensure brevity in your answer.  0.59. What is the ratio of the Cost (current US$) of Energy in 1975 to that in 1980?
Provide a short and direct response. 0.35. What is the ratio of the Cost (current US$) in Forest in 1975 to that in 1980?
Your response must be concise. 0.76. What is the ratio of the Cost (current US$) of CO2 damage in 1975 to that in 1981?
Your answer should be compact. 0.41. What is the ratio of the Cost (current US$) of Minerals in 1975 to that in 1981?
Your answer should be very brief. 0.58. What is the ratio of the Cost (current US$) in Energy in 1975 to that in 1981?
Give a very brief answer. 0.2. What is the ratio of the Cost (current US$) in Forest in 1975 to that in 1981?
Your answer should be very brief. 0.93. What is the ratio of the Cost (current US$) of CO2 damage in 1976 to that in 1977?
Offer a very short reply. 0.78. What is the ratio of the Cost (current US$) in Minerals in 1976 to that in 1977?
Provide a short and direct response. 1.03. What is the ratio of the Cost (current US$) in Energy in 1976 to that in 1977?
Ensure brevity in your answer.  0.82. What is the ratio of the Cost (current US$) in Forest in 1976 to that in 1977?
Your response must be concise. 0.71. What is the ratio of the Cost (current US$) in CO2 damage in 1976 to that in 1978?
Provide a succinct answer. 0.71. What is the ratio of the Cost (current US$) of Minerals in 1976 to that in 1978?
Give a very brief answer. 1.36. What is the ratio of the Cost (current US$) of Energy in 1976 to that in 1978?
Your answer should be compact. 0.81. What is the ratio of the Cost (current US$) of Forest in 1976 to that in 1978?
Provide a succinct answer. 0.71. What is the ratio of the Cost (current US$) of CO2 damage in 1976 to that in 1979?
Provide a succinct answer. 0.62. What is the ratio of the Cost (current US$) in Minerals in 1976 to that in 1979?
Provide a succinct answer. 1.09. What is the ratio of the Cost (current US$) of Energy in 1976 to that in 1979?
Your response must be concise. 0.43. What is the ratio of the Cost (current US$) of Forest in 1976 to that in 1979?
Offer a terse response. 0.63. What is the ratio of the Cost (current US$) in CO2 damage in 1976 to that in 1980?
Provide a succinct answer. 0.54. What is the ratio of the Cost (current US$) of Minerals in 1976 to that in 1980?
Ensure brevity in your answer.  0.88. What is the ratio of the Cost (current US$) of Energy in 1976 to that in 1980?
Provide a succinct answer. 0.38. What is the ratio of the Cost (current US$) in Forest in 1976 to that in 1980?
Your answer should be compact. 0.5. What is the ratio of the Cost (current US$) of CO2 damage in 1976 to that in 1981?
Offer a very short reply. 0.45. What is the ratio of the Cost (current US$) in Minerals in 1976 to that in 1981?
Keep it short and to the point. 0.87. What is the ratio of the Cost (current US$) of Energy in 1976 to that in 1981?
Provide a short and direct response. 0.23. What is the ratio of the Cost (current US$) in Forest in 1976 to that in 1981?
Ensure brevity in your answer.  0.62. What is the ratio of the Cost (current US$) in CO2 damage in 1977 to that in 1978?
Ensure brevity in your answer.  0.92. What is the ratio of the Cost (current US$) of Minerals in 1977 to that in 1978?
Make the answer very short. 1.32. What is the ratio of the Cost (current US$) in Forest in 1977 to that in 1978?
Offer a very short reply. 1. What is the ratio of the Cost (current US$) in CO2 damage in 1977 to that in 1979?
Offer a very short reply. 0.8. What is the ratio of the Cost (current US$) of Minerals in 1977 to that in 1979?
Offer a very short reply. 1.06. What is the ratio of the Cost (current US$) in Energy in 1977 to that in 1979?
Make the answer very short. 0.52. What is the ratio of the Cost (current US$) in Forest in 1977 to that in 1979?
Ensure brevity in your answer.  0.89. What is the ratio of the Cost (current US$) of CO2 damage in 1977 to that in 1980?
Keep it short and to the point. 0.69. What is the ratio of the Cost (current US$) in Minerals in 1977 to that in 1980?
Offer a very short reply. 0.86. What is the ratio of the Cost (current US$) of Energy in 1977 to that in 1980?
Your answer should be very brief. 0.47. What is the ratio of the Cost (current US$) of Forest in 1977 to that in 1980?
Offer a very short reply. 0.71. What is the ratio of the Cost (current US$) of CO2 damage in 1977 to that in 1981?
Offer a very short reply. 0.58. What is the ratio of the Cost (current US$) in Minerals in 1977 to that in 1981?
Offer a very short reply. 0.84. What is the ratio of the Cost (current US$) in Energy in 1977 to that in 1981?
Ensure brevity in your answer.  0.28. What is the ratio of the Cost (current US$) in Forest in 1977 to that in 1981?
Your answer should be compact. 0.87. What is the ratio of the Cost (current US$) in CO2 damage in 1978 to that in 1979?
Your answer should be compact. 0.87. What is the ratio of the Cost (current US$) in Minerals in 1978 to that in 1979?
Your answer should be very brief. 0.8. What is the ratio of the Cost (current US$) in Energy in 1978 to that in 1979?
Offer a very short reply. 0.53. What is the ratio of the Cost (current US$) of Forest in 1978 to that in 1979?
Keep it short and to the point. 0.89. What is the ratio of the Cost (current US$) of CO2 damage in 1978 to that in 1980?
Give a very brief answer. 0.76. What is the ratio of the Cost (current US$) of Minerals in 1978 to that in 1980?
Provide a succinct answer. 0.65. What is the ratio of the Cost (current US$) of Energy in 1978 to that in 1980?
Offer a very short reply. 0.47. What is the ratio of the Cost (current US$) in Forest in 1978 to that in 1980?
Your answer should be compact. 0.71. What is the ratio of the Cost (current US$) of CO2 damage in 1978 to that in 1981?
Make the answer very short. 0.63. What is the ratio of the Cost (current US$) of Minerals in 1978 to that in 1981?
Your answer should be compact. 0.64. What is the ratio of the Cost (current US$) in Energy in 1978 to that in 1981?
Provide a succinct answer. 0.28. What is the ratio of the Cost (current US$) of Forest in 1978 to that in 1981?
Your response must be concise. 0.87. What is the ratio of the Cost (current US$) in CO2 damage in 1979 to that in 1980?
Provide a succinct answer. 0.86. What is the ratio of the Cost (current US$) of Minerals in 1979 to that in 1980?
Your response must be concise. 0.81. What is the ratio of the Cost (current US$) of Energy in 1979 to that in 1980?
Your response must be concise. 0.89. What is the ratio of the Cost (current US$) in CO2 damage in 1979 to that in 1981?
Your answer should be very brief. 0.73. What is the ratio of the Cost (current US$) of Minerals in 1979 to that in 1981?
Offer a terse response. 0.8. What is the ratio of the Cost (current US$) of Energy in 1979 to that in 1981?
Offer a terse response. 0.53. What is the ratio of the Cost (current US$) in Forest in 1979 to that in 1981?
Keep it short and to the point. 0.98. What is the ratio of the Cost (current US$) in CO2 damage in 1980 to that in 1981?
Offer a terse response. 0.84. What is the ratio of the Cost (current US$) in Minerals in 1980 to that in 1981?
Ensure brevity in your answer.  0.99. What is the ratio of the Cost (current US$) in Energy in 1980 to that in 1981?
Provide a succinct answer. 0.59. What is the ratio of the Cost (current US$) of Forest in 1980 to that in 1981?
Make the answer very short. 1.23. What is the difference between the highest and the second highest Cost (current US$) of CO2 damage?
Make the answer very short. 1.93e+08. What is the difference between the highest and the second highest Cost (current US$) in Minerals?
Your response must be concise. 3.63e+06. What is the difference between the highest and the second highest Cost (current US$) in Energy?
Provide a short and direct response. 1.52e+09. What is the difference between the highest and the second highest Cost (current US$) in Forest?
Keep it short and to the point. 1.07e+09. What is the difference between the highest and the lowest Cost (current US$) in CO2 damage?
Your response must be concise. 7.20e+08. What is the difference between the highest and the lowest Cost (current US$) in Minerals?
Give a very brief answer. 1.05e+08. What is the difference between the highest and the lowest Cost (current US$) of Energy?
Provide a succinct answer. 2.98e+09. What is the difference between the highest and the lowest Cost (current US$) of Forest?
Give a very brief answer. 2.84e+09. 